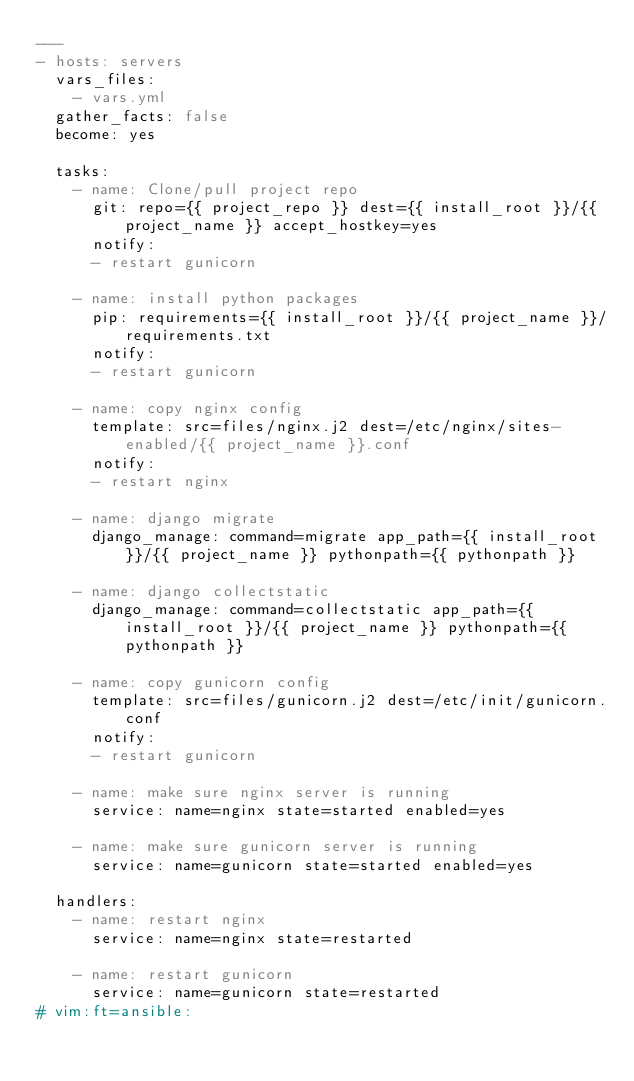Convert code to text. <code><loc_0><loc_0><loc_500><loc_500><_YAML_>---
- hosts: servers
  vars_files:
    - vars.yml
  gather_facts: false
  become: yes

  tasks:
    - name: Clone/pull project repo
      git: repo={{ project_repo }} dest={{ install_root }}/{{ project_name }} accept_hostkey=yes
      notify:
      - restart gunicorn

    - name: install python packages
      pip: requirements={{ install_root }}/{{ project_name }}/requirements.txt
      notify:
      - restart gunicorn

    - name: copy nginx config
      template: src=files/nginx.j2 dest=/etc/nginx/sites-enabled/{{ project_name }}.conf
      notify:
      - restart nginx

    - name: django migrate
      django_manage: command=migrate app_path={{ install_root }}/{{ project_name }} pythonpath={{ pythonpath }}

    - name: django collectstatic
      django_manage: command=collectstatic app_path={{ install_root }}/{{ project_name }} pythonpath={{ pythonpath }}

    - name: copy gunicorn config
      template: src=files/gunicorn.j2 dest=/etc/init/gunicorn.conf
      notify:
      - restart gunicorn

    - name: make sure nginx server is running
      service: name=nginx state=started enabled=yes

    - name: make sure gunicorn server is running
      service: name=gunicorn state=started enabled=yes

  handlers: 
    - name: restart nginx
      service: name=nginx state=restarted

    - name: restart gunicorn
      service: name=gunicorn state=restarted
# vim:ft=ansible:
</code> 